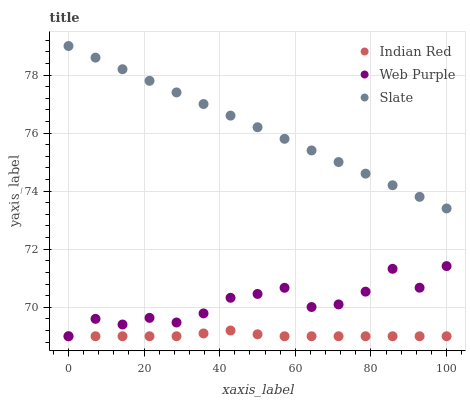Does Indian Red have the minimum area under the curve?
Answer yes or no. Yes. Does Slate have the maximum area under the curve?
Answer yes or no. Yes. Does Slate have the minimum area under the curve?
Answer yes or no. No. Does Indian Red have the maximum area under the curve?
Answer yes or no. No. Is Slate the smoothest?
Answer yes or no. Yes. Is Web Purple the roughest?
Answer yes or no. Yes. Is Indian Red the smoothest?
Answer yes or no. No. Is Indian Red the roughest?
Answer yes or no. No. Does Web Purple have the lowest value?
Answer yes or no. Yes. Does Slate have the lowest value?
Answer yes or no. No. Does Slate have the highest value?
Answer yes or no. Yes. Does Indian Red have the highest value?
Answer yes or no. No. Is Indian Red less than Slate?
Answer yes or no. Yes. Is Slate greater than Web Purple?
Answer yes or no. Yes. Does Web Purple intersect Indian Red?
Answer yes or no. Yes. Is Web Purple less than Indian Red?
Answer yes or no. No. Is Web Purple greater than Indian Red?
Answer yes or no. No. Does Indian Red intersect Slate?
Answer yes or no. No. 